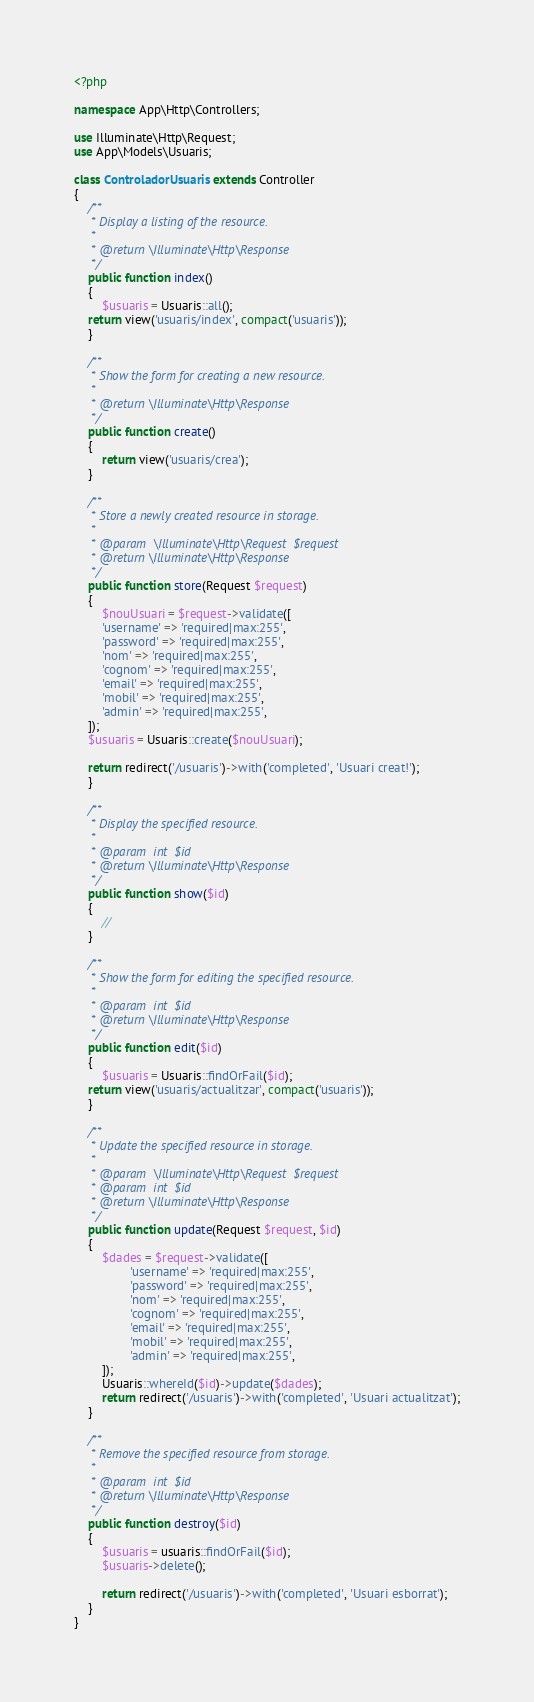Convert code to text. <code><loc_0><loc_0><loc_500><loc_500><_PHP_><?php

namespace App\Http\Controllers;

use Illuminate\Http\Request;
use App\Models\Usuaris;

class ControladorUsuaris extends Controller
{
    /**
     * Display a listing of the resource.
     *
     * @return \Illuminate\Http\Response
     */
    public function index()
    {
        $usuaris = Usuaris::all();
	return view('usuaris/index', compact('usuaris'));
    }

    /**
     * Show the form for creating a new resource.
     *
     * @return \Illuminate\Http\Response
     */
    public function create()
    {
        return view('usuaris/crea');
    }

    /**
     * Store a newly created resource in storage.
     *
     * @param  \Illuminate\Http\Request  $request
     * @return \Illuminate\Http\Response
     */
    public function store(Request $request)
    {
        $nouUsuari = $request->validate([
		'username' => 'required|max:255',
		'password' => 'required|max:255',
		'nom' => 'required|max:255',
		'cognom' => 'required|max:255',
		'email' => 'required|max:255',
		'mobil' => 'required|max:255',
		'admin' => 'required|max:255',
	]);
	$usuaris = Usuaris::create($nouUsuari);

	return redirect('/usuaris')->with('completed', 'Usuari creat!');
    }

    /**
     * Display the specified resource.
     *
     * @param  int  $id
     * @return \Illuminate\Http\Response
     */
    public function show($id)
    {
        //
    }

    /**
     * Show the form for editing the specified resource.
     *
     * @param  int  $id
     * @return \Illuminate\Http\Response
     */
    public function edit($id)
    {
        $usuaris = Usuaris::findOrFail($id);
	return view('usuaris/actualitzar', compact('usuaris'));
    }

    /**
     * Update the specified resource in storage.
     *
     * @param  \Illuminate\Http\Request  $request
     * @param  int  $id
     * @return \Illuminate\Http\Response
     */
    public function update(Request $request, $id)
    {
        $dades = $request->validate([
                'username' => 'required|max:255',
                'password' => 'required|max:255',
                'nom' => 'required|max:255',
                'cognom' => 'required|max:255',
                'email' => 'required|max:255',
                'mobil' => 'required|max:255',
                'admin' => 'required|max:255',
        ]);
        Usuaris::whereId($id)->update($dades);
        return redirect('/usuaris')->with('completed', 'Usuari actualitzat');
    }

    /**
     * Remove the specified resource from storage.
     *
     * @param  int  $id
     * @return \Illuminate\Http\Response
     */
    public function destroy($id)
    {
        $usuaris = usuaris::findOrFail($id);
        $usuaris->delete();

        return redirect('/usuaris')->with('completed', 'Usuari esborrat');
    }
}
</code> 